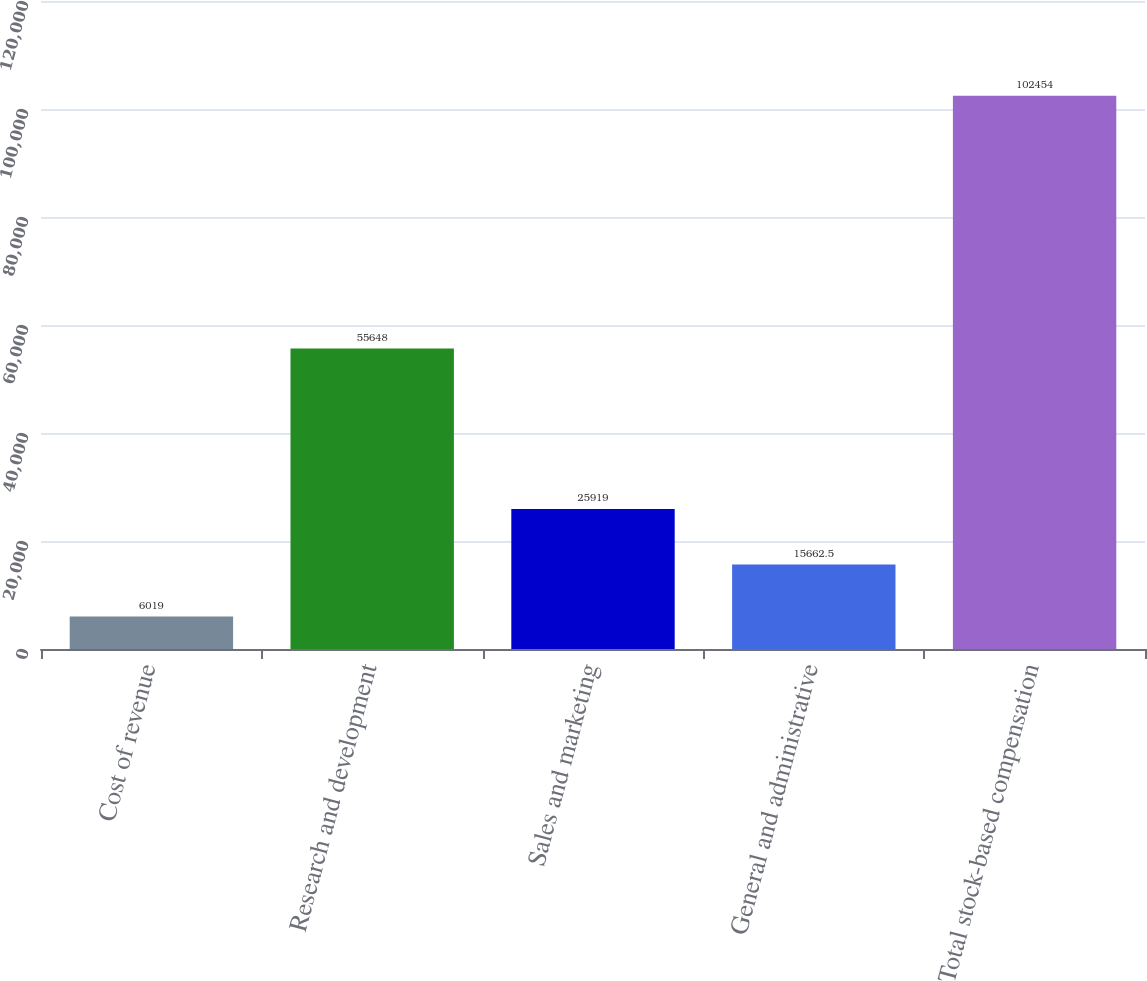Convert chart to OTSL. <chart><loc_0><loc_0><loc_500><loc_500><bar_chart><fcel>Cost of revenue<fcel>Research and development<fcel>Sales and marketing<fcel>General and administrative<fcel>Total stock-based compensation<nl><fcel>6019<fcel>55648<fcel>25919<fcel>15662.5<fcel>102454<nl></chart> 